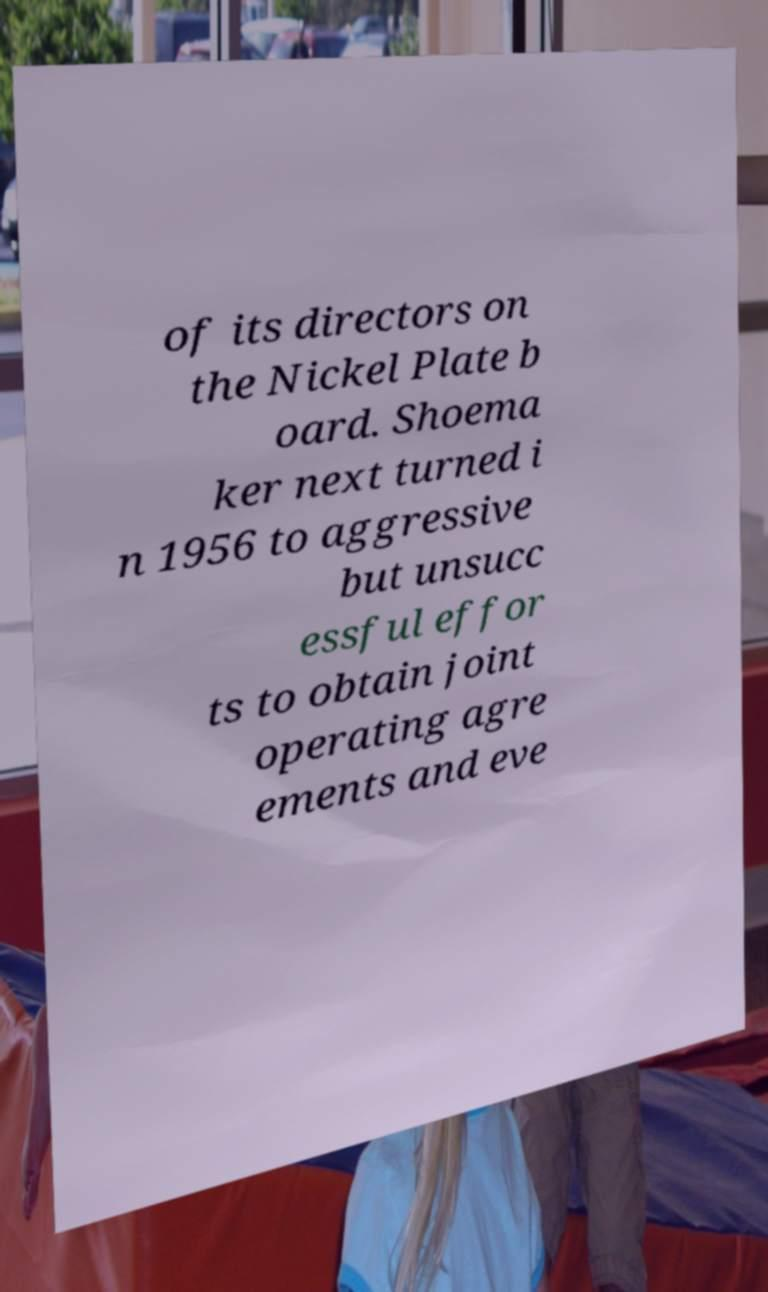Could you extract and type out the text from this image? of its directors on the Nickel Plate b oard. Shoema ker next turned i n 1956 to aggressive but unsucc essful effor ts to obtain joint operating agre ements and eve 